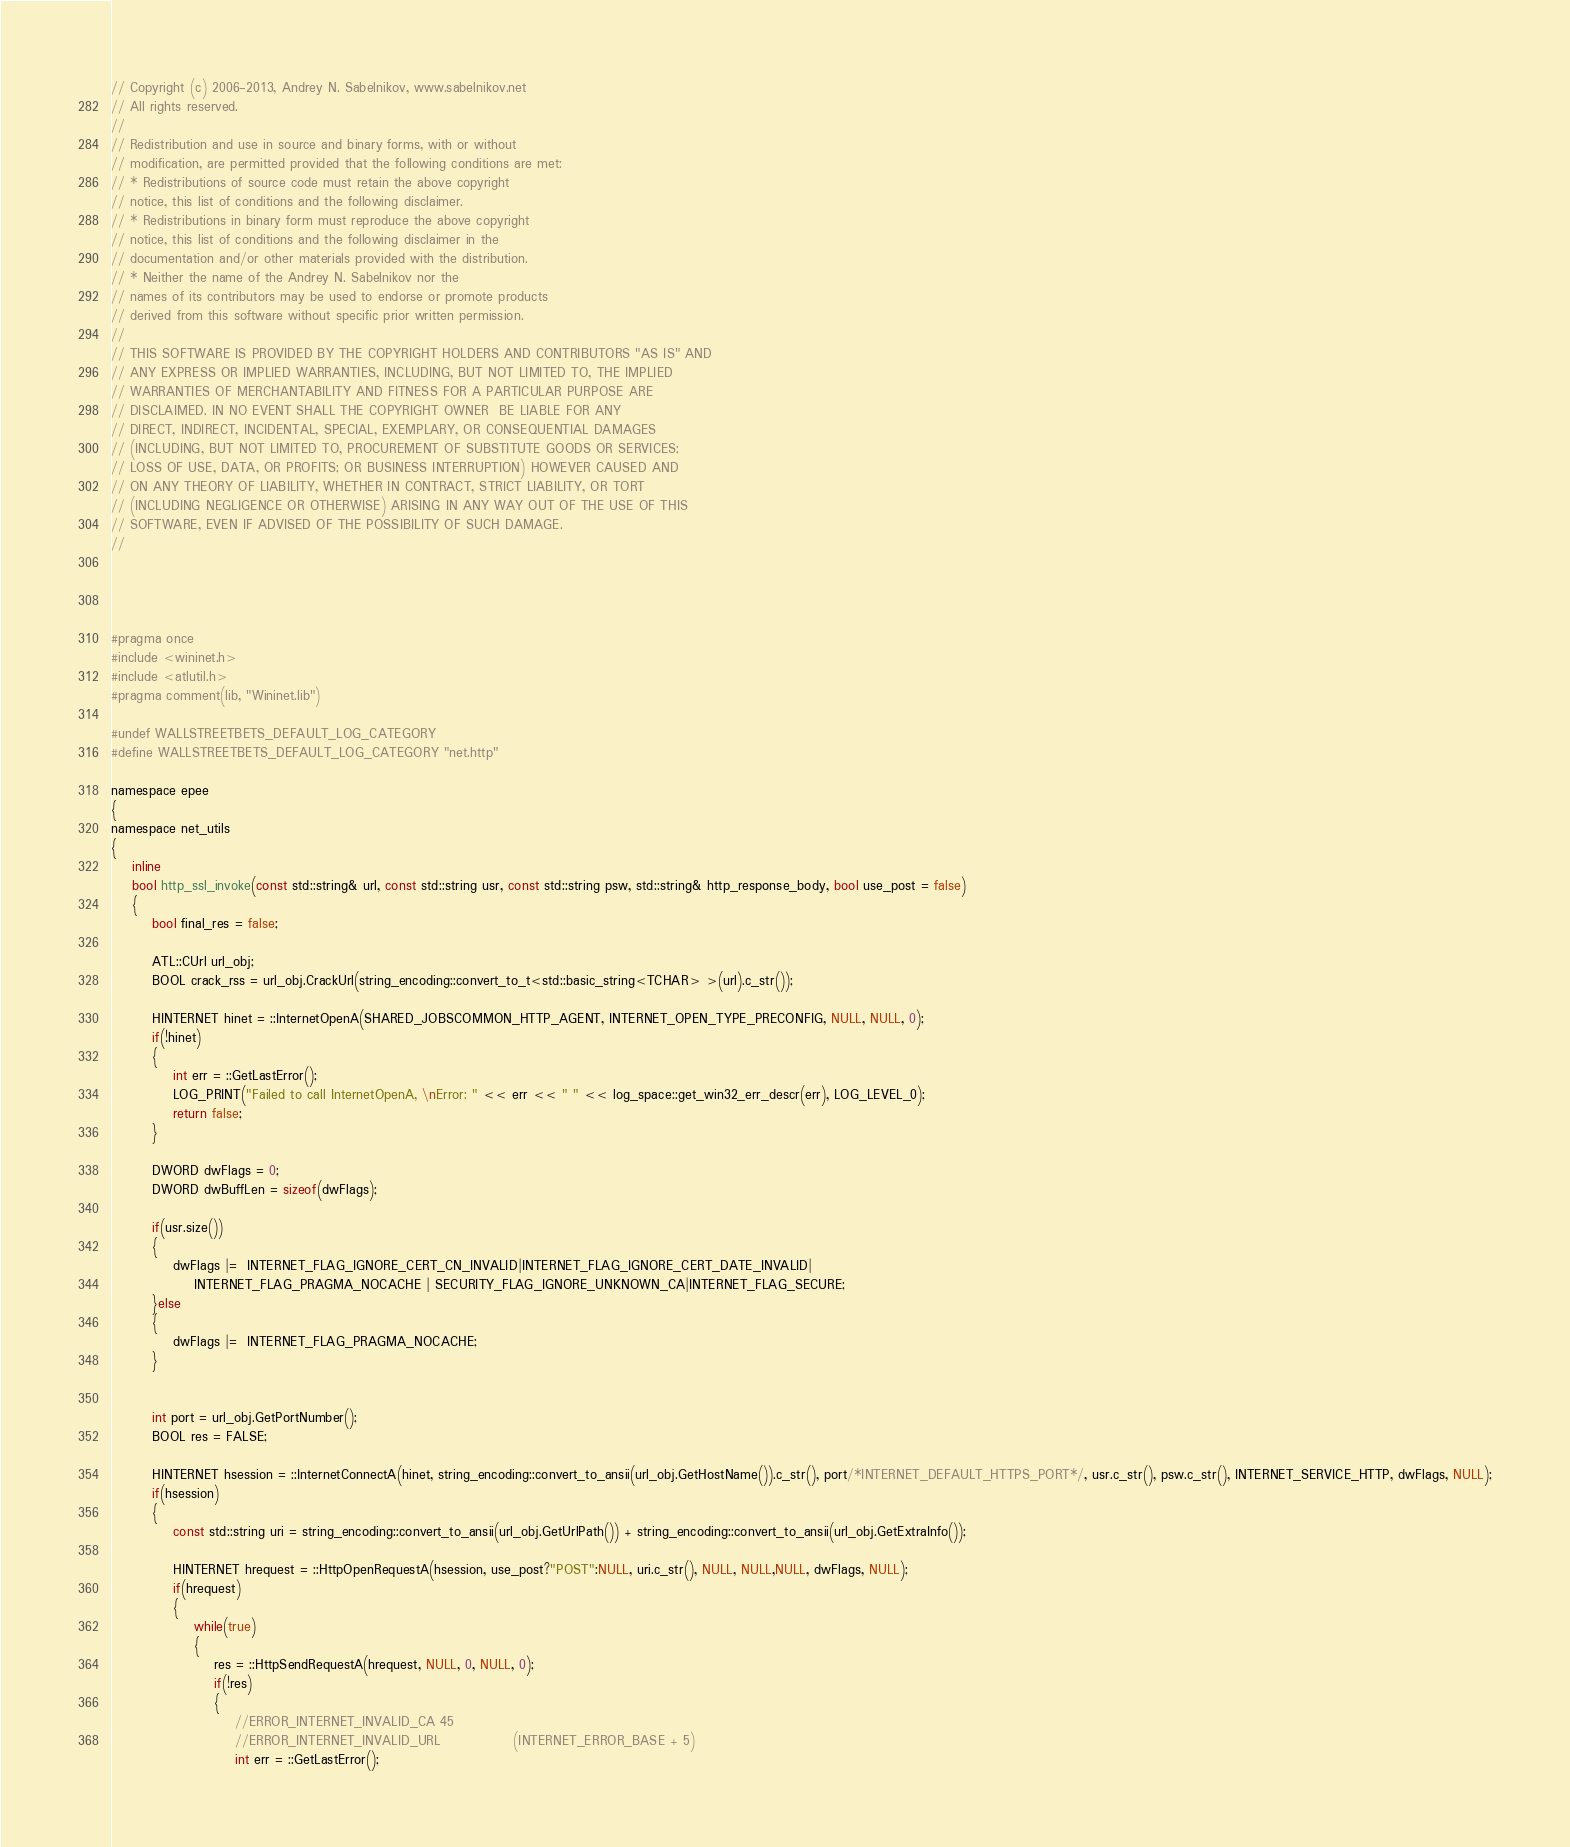<code> <loc_0><loc_0><loc_500><loc_500><_C_>// Copyright (c) 2006-2013, Andrey N. Sabelnikov, www.sabelnikov.net
// All rights reserved.
// 
// Redistribution and use in source and binary forms, with or without
// modification, are permitted provided that the following conditions are met:
// * Redistributions of source code must retain the above copyright
// notice, this list of conditions and the following disclaimer.
// * Redistributions in binary form must reproduce the above copyright
// notice, this list of conditions and the following disclaimer in the
// documentation and/or other materials provided with the distribution.
// * Neither the name of the Andrey N. Sabelnikov nor the
// names of its contributors may be used to endorse or promote products
// derived from this software without specific prior written permission.
// 
// THIS SOFTWARE IS PROVIDED BY THE COPYRIGHT HOLDERS AND CONTRIBUTORS "AS IS" AND
// ANY EXPRESS OR IMPLIED WARRANTIES, INCLUDING, BUT NOT LIMITED TO, THE IMPLIED
// WARRANTIES OF MERCHANTABILITY AND FITNESS FOR A PARTICULAR PURPOSE ARE
// DISCLAIMED. IN NO EVENT SHALL THE COPYRIGHT OWNER  BE LIABLE FOR ANY
// DIRECT, INDIRECT, INCIDENTAL, SPECIAL, EXEMPLARY, OR CONSEQUENTIAL DAMAGES
// (INCLUDING, BUT NOT LIMITED TO, PROCUREMENT OF SUBSTITUTE GOODS OR SERVICES;
// LOSS OF USE, DATA, OR PROFITS; OR BUSINESS INTERRUPTION) HOWEVER CAUSED AND
// ON ANY THEORY OF LIABILITY, WHETHER IN CONTRACT, STRICT LIABILITY, OR TORT
// (INCLUDING NEGLIGENCE OR OTHERWISE) ARISING IN ANY WAY OUT OF THE USE OF THIS
// SOFTWARE, EVEN IF ADVISED OF THE POSSIBILITY OF SUCH DAMAGE.
// 




#pragma once 
#include <wininet.h>
#include <atlutil.h>
#pragma comment(lib, "Wininet.lib")

#undef WALLSTREETBETS_DEFAULT_LOG_CATEGORY
#define WALLSTREETBETS_DEFAULT_LOG_CATEGORY "net.http"

namespace epee
{
namespace net_utils
{
	inline 
	bool http_ssl_invoke(const std::string& url, const std::string usr, const std::string psw, std::string& http_response_body, bool use_post = false)
	{
		bool final_res = false;

		ATL::CUrl url_obj;
		BOOL crack_rss = url_obj.CrackUrl(string_encoding::convert_to_t<std::basic_string<TCHAR> >(url).c_str());

		HINTERNET hinet = ::InternetOpenA(SHARED_JOBSCOMMON_HTTP_AGENT, INTERNET_OPEN_TYPE_PRECONFIG, NULL, NULL, 0);
		if(!hinet)
		{
			int err = ::GetLastError();
			LOG_PRINT("Failed to call InternetOpenA, \nError: " << err << " " << log_space::get_win32_err_descr(err), LOG_LEVEL_0);
			return false;
		}

		DWORD dwFlags = 0;
		DWORD dwBuffLen = sizeof(dwFlags);

		if(usr.size())
		{
			dwFlags |=  INTERNET_FLAG_IGNORE_CERT_CN_INVALID|INTERNET_FLAG_IGNORE_CERT_DATE_INVALID|
				INTERNET_FLAG_PRAGMA_NOCACHE | SECURITY_FLAG_IGNORE_UNKNOWN_CA|INTERNET_FLAG_SECURE; 
		}else
		{
			dwFlags |=  INTERNET_FLAG_PRAGMA_NOCACHE; 
		}


		int port = url_obj.GetPortNumber();
		BOOL res = FALSE;

		HINTERNET hsession = ::InternetConnectA(hinet, string_encoding::convert_to_ansii(url_obj.GetHostName()).c_str(), port/*INTERNET_DEFAULT_HTTPS_PORT*/, usr.c_str(), psw.c_str(), INTERNET_SERVICE_HTTP, dwFlags, NULL);
		if(hsession)
		{
			const std::string uri = string_encoding::convert_to_ansii(url_obj.GetUrlPath()) + string_encoding::convert_to_ansii(url_obj.GetExtraInfo());

			HINTERNET hrequest = ::HttpOpenRequestA(hsession, use_post?"POST":NULL, uri.c_str(), NULL, NULL,NULL, dwFlags, NULL);
			if(hrequest)
			{
				while(true)
				{
					res = ::HttpSendRequestA(hrequest, NULL, 0, NULL, 0);
					if(!res)
					{
						//ERROR_INTERNET_INVALID_CA 45
						//ERROR_INTERNET_INVALID_URL              (INTERNET_ERROR_BASE + 5)
						int err = ::GetLastError();</code> 